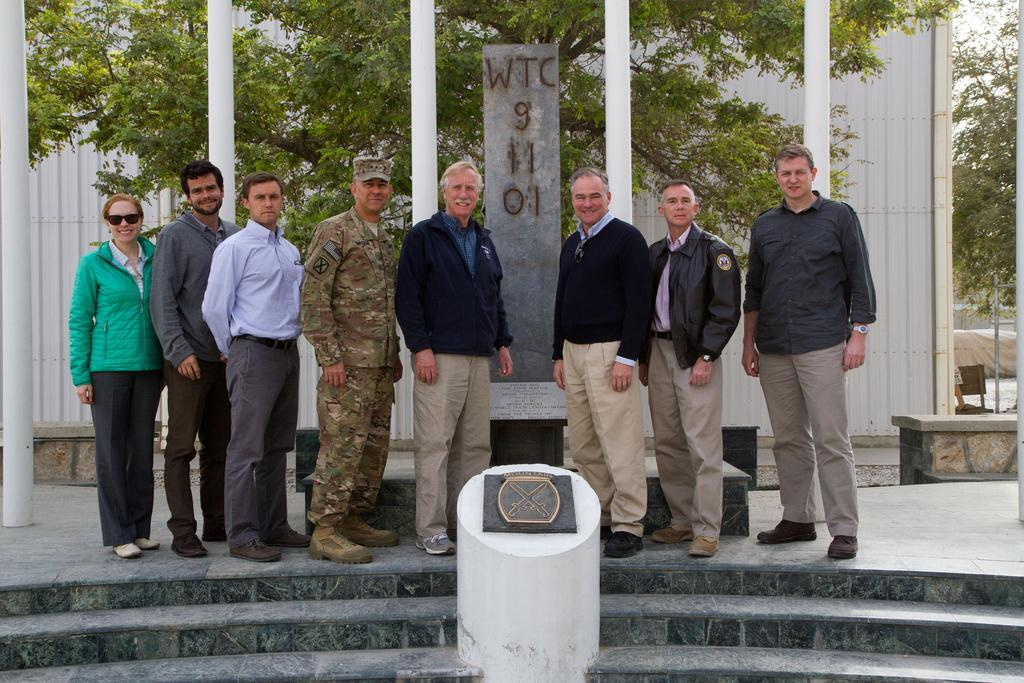What can be seen in the image involving people? There are people standing in the image. What architectural feature is present in the image? There are stairs in the image. What artistic element is visible in the image? There is a sculpture in the image. What type of natural elements can be seen in the background of the image? There are trees in the background of the image. What man-made structures are visible in the background of the image? There are concrete poles and a wall in the background of the image. What type of cushion is being used by the actor in the image? There is no actor or cushion present in the image. How many pies are being held by the people in the image? There are no pies visible in the image; only people, stairs, a sculpture, trees, concrete poles, and a wall are present. 